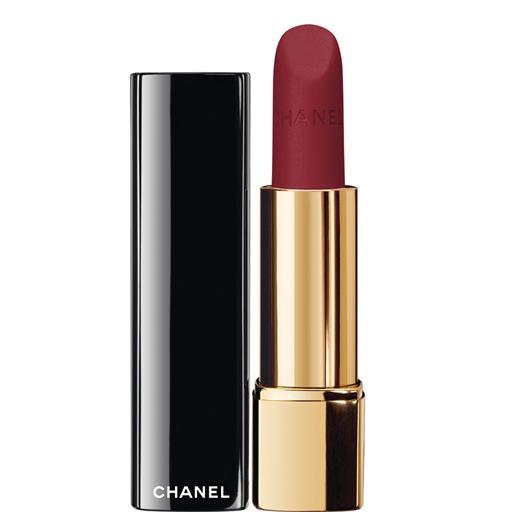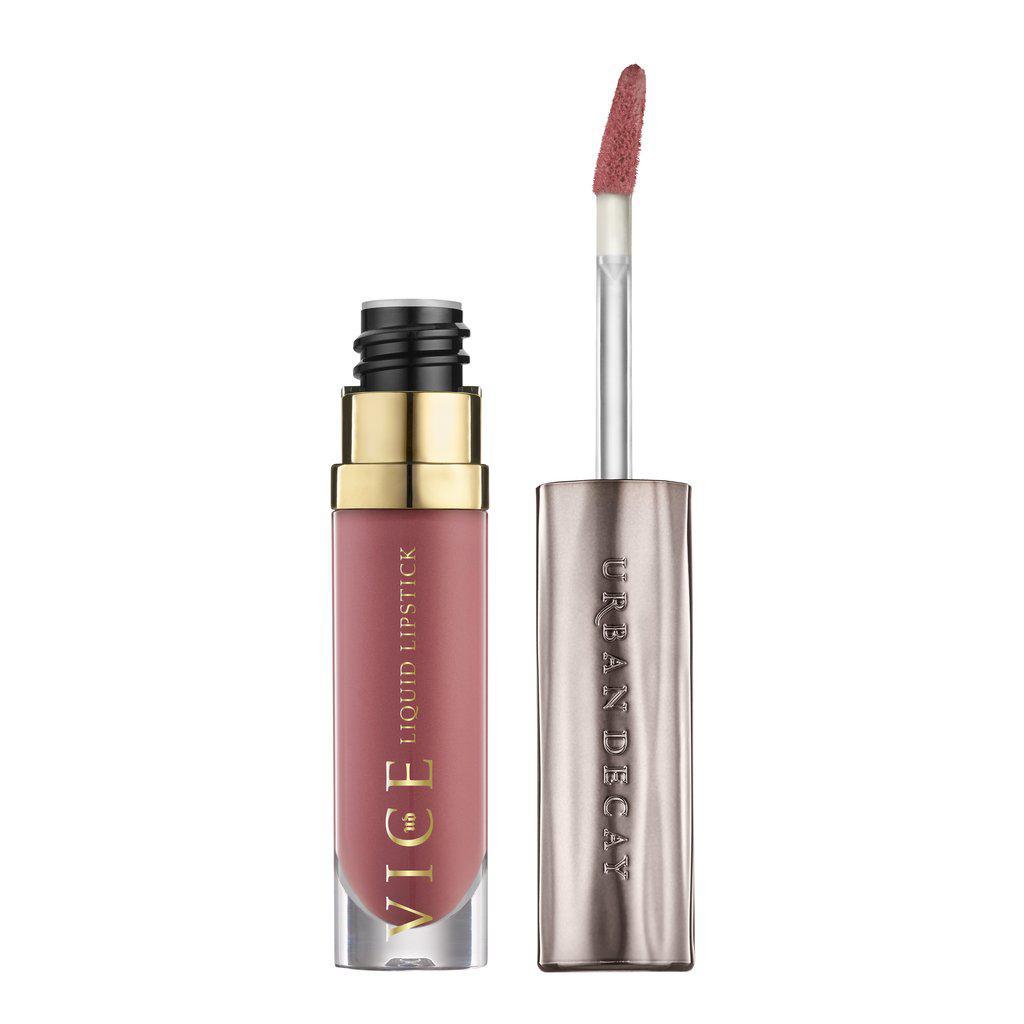The first image is the image on the left, the second image is the image on the right. Assess this claim about the two images: "A red lipstick in one image is in a silver holder with black base, with a matching black cap with silver band sitting upright and level beside it.". Correct or not? Answer yes or no. No. The first image is the image on the left, the second image is the image on the right. For the images shown, is this caption "A red lipstick in a silver tube is displayed level to and alongside of its upright black cap." true? Answer yes or no. No. 